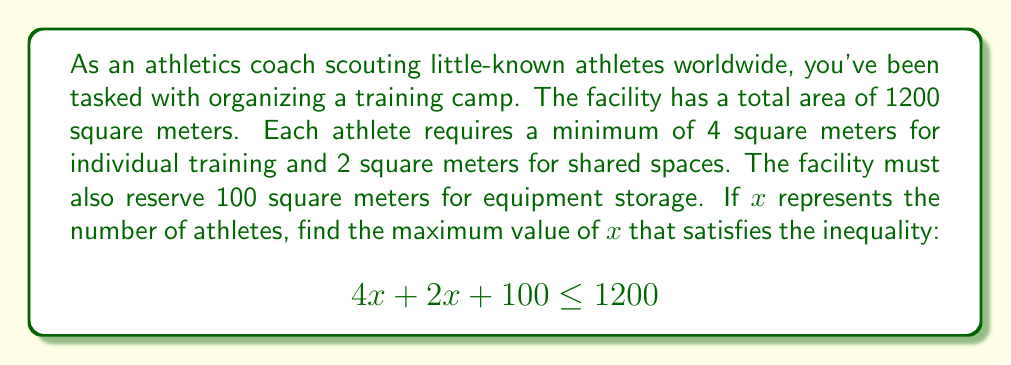Can you answer this question? Let's approach this step-by-step:

1) First, let's understand what each part of the inequality represents:
   - $4x$ represents the individual training space (4 sq m per athlete)
   - $2x$ represents the shared space (2 sq m per athlete)
   - 100 represents the equipment storage space
   - 1200 is the total available area

2) Simplify the left side of the inequality:
   $$(4x + 2x) + 100 \leq 1200$$
   $$6x + 100 \leq 1200$$

3) Subtract 100 from both sides:
   $$6x \leq 1100$$

4) Divide both sides by 6:
   $$x \leq \frac{1100}{6}$$

5) Simplify:
   $$x \leq 183.33$$

6) Since $x$ represents the number of athletes, it must be a whole number. Therefore, we need to round down to the nearest integer.
Answer: The maximum number of athletes that can be accommodated is 183. 